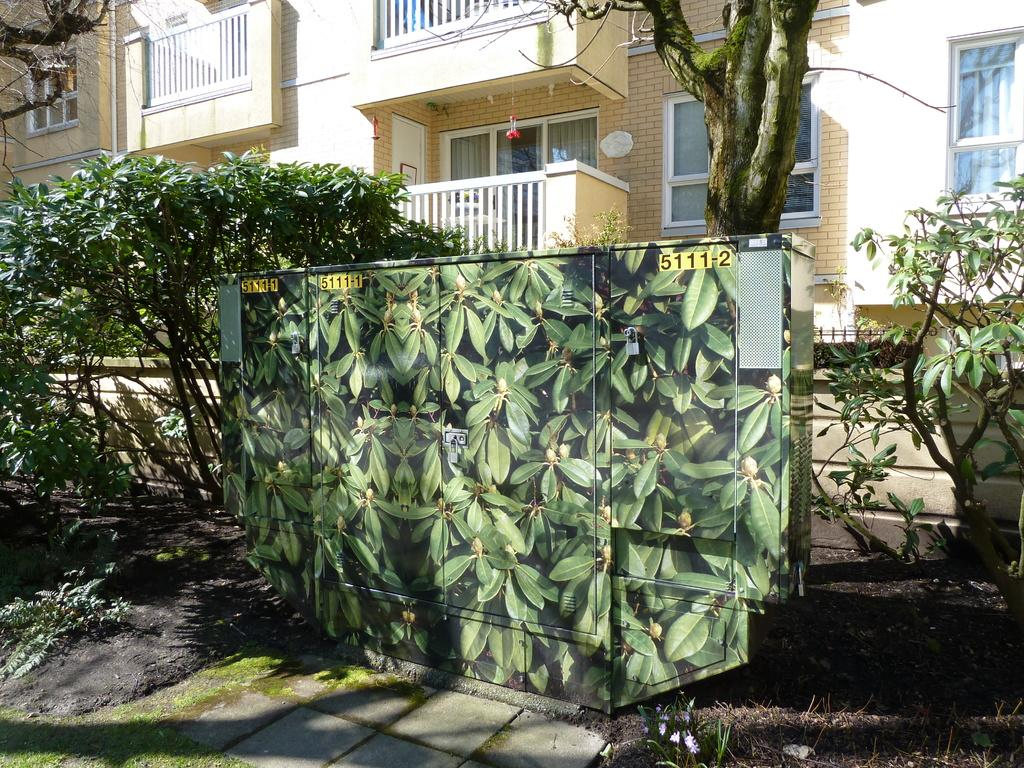What type of living organisms can be seen in the image? Plants can be seen in the image. What can be seen in the background of the image? There is a building and windows visible in the background of the image. What type of drug can be seen in the image? There is no drug present in the image; it features plants and a building in the background. 